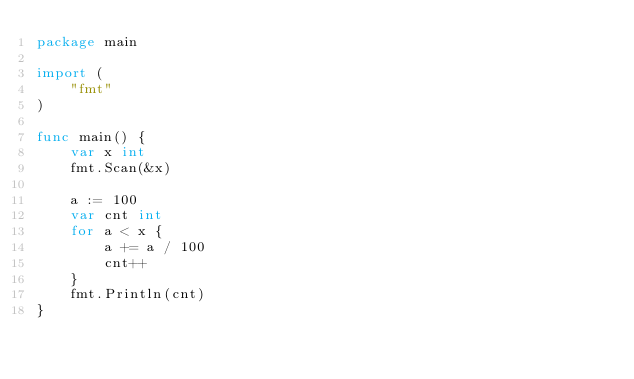<code> <loc_0><loc_0><loc_500><loc_500><_Go_>package main

import (
	"fmt"
)

func main() {
	var x int
	fmt.Scan(&x)

	a := 100
	var cnt int
	for a < x {
		a += a / 100
		cnt++
	}
	fmt.Println(cnt)
}
</code> 